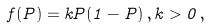<formula> <loc_0><loc_0><loc_500><loc_500>f ( P ) = k P ( 1 - P ) \, , k > 0 \, ,</formula> 